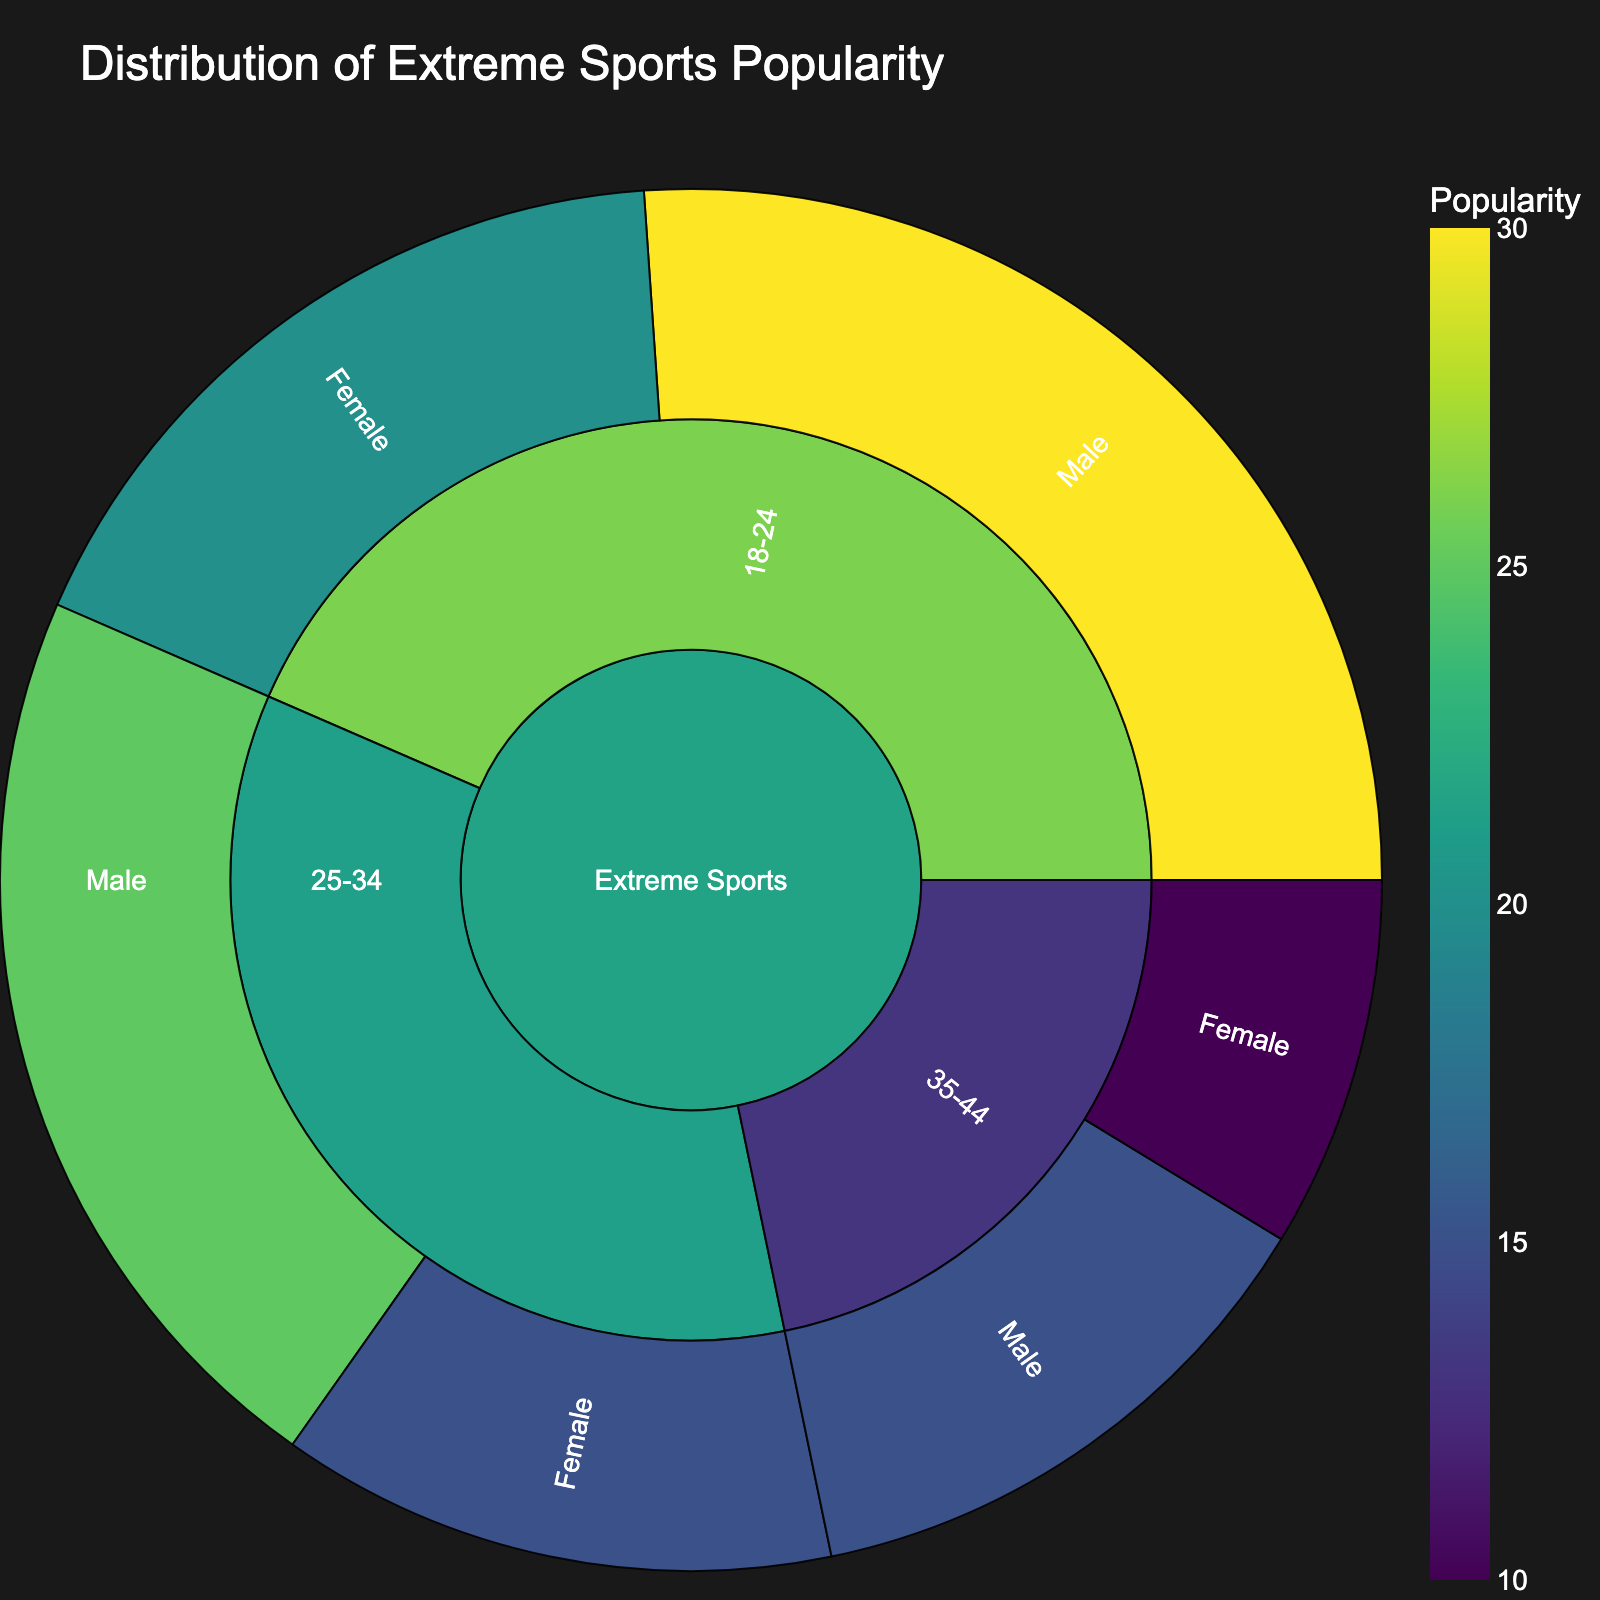Which age group and gender has the highest popularity in Extreme Sports? Observe the segments in the Sunburst Plot. The largest outer segment representing the highest popularity value corresponds to the "18-24" age group and "Male" gender.
Answer: 18-24, Male What is the total popularity of Extreme Sports for the age group 35-44? Sum the popularity of both male and female segments within the 35-44 age group. Male is 15 and female is 10, thus total popularity is 15 + 10.
Answer: 25 Compare the popularity of Extreme Sports between males and females in the 25-34 age group. Inspect the segments for the "25-34" age group; the male segment has a popularity of 25 and the female segment has a popularity of 15.
Answer: Male is more popular than Female What's the difference in popularity between the 18-24 and 35-44 age groups for males? Refer to the male segments of both age groups. For 18-24, it's 30, and for 35-44, it's 15. Subtract the two values, 30 - 15.
Answer: 15 Which gender shows the least interest in extreme sports? Identify the smallest segment in the plot. The smallest value is found in the "35-44" age group for females, with a popularity of 10.
Answer: Female, 35-44 Calculate the average popularity of Extreme Sports for the age group 18-24. Sum the male and female popularity for 18-24 age group and divide by 2. The popularity values are 30 (Male) and 20 (Female), so (30+20)/2.
Answer: 25 What's the proportion of total popularity contributed by the 25-34 age group for both genders? Calculate the combined popularity for 25-34 age group (Male: 25, Female: 15) making it 40. Sum all popularity values (30+20+25+15+15+10 = 115). Proportion is 40/115.
Answer: ~0.35 (or 35%) Within the 35-44 age group, how much more popular is extreme sports among males compared to females? Find the difference between male and female popularity in the 35-44 age group. The values are 15 (Male) and 10 (Female). Difference = 15 - 10.
Answer: 5 Which age group contributes the most to the total popularity of extreme sports across both genders? Sum the popularity values for both genders within each age group. 18-24: 30+20=50, 25-34: 25+15=40, 35-44: 15+10=25. Thus, the 18-24 age group is the highest.
Answer: 18-24 What's the total popularity of Extreme Sports for females across all age groups? Sum the popularity values for females in all age groups. The values are 18-24: 20, 25-34: 15, 35-44: 10. Total = 20 + 15 + 10.
Answer: 45 